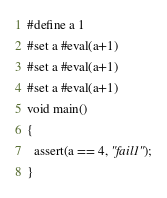<code> <loc_0><loc_0><loc_500><loc_500><_C_>#define a 1
#set a #eval(a+1)
#set a #eval(a+1)
#set a #eval(a+1)
void main()
{
  assert(a == 4, "fail1");
}</code> 